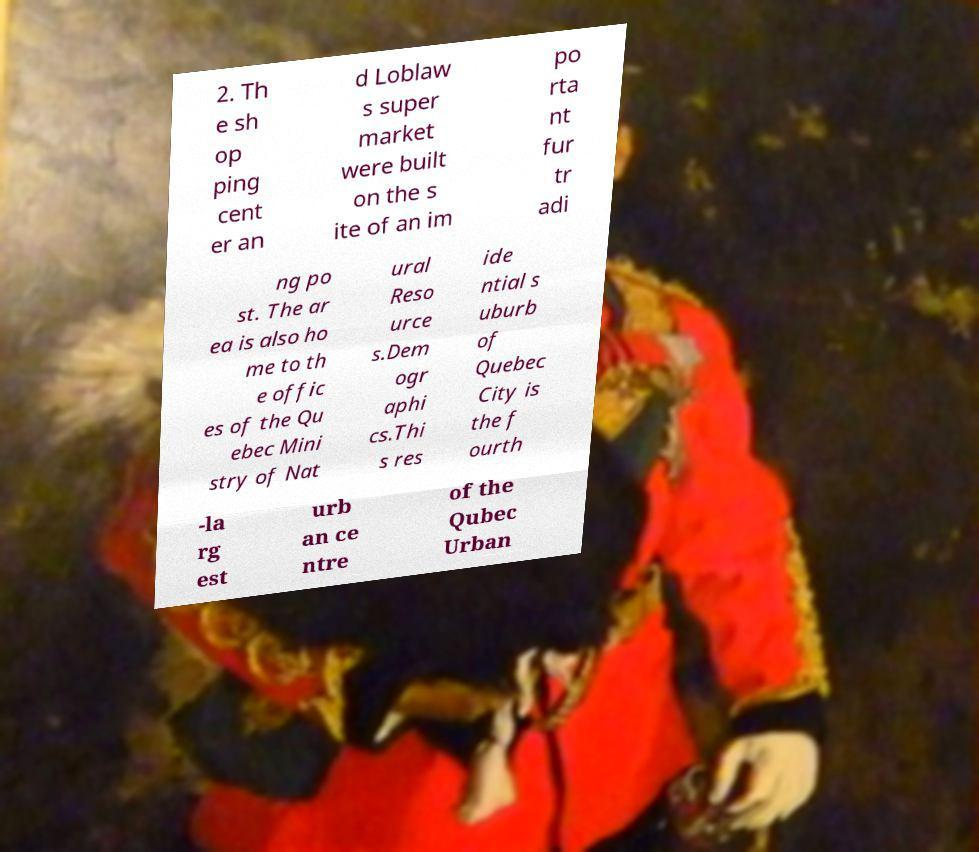Please identify and transcribe the text found in this image. 2. Th e sh op ping cent er an d Loblaw s super market were built on the s ite of an im po rta nt fur tr adi ng po st. The ar ea is also ho me to th e offic es of the Qu ebec Mini stry of Nat ural Reso urce s.Dem ogr aphi cs.Thi s res ide ntial s uburb of Quebec City is the f ourth -la rg est urb an ce ntre of the Qubec Urban 